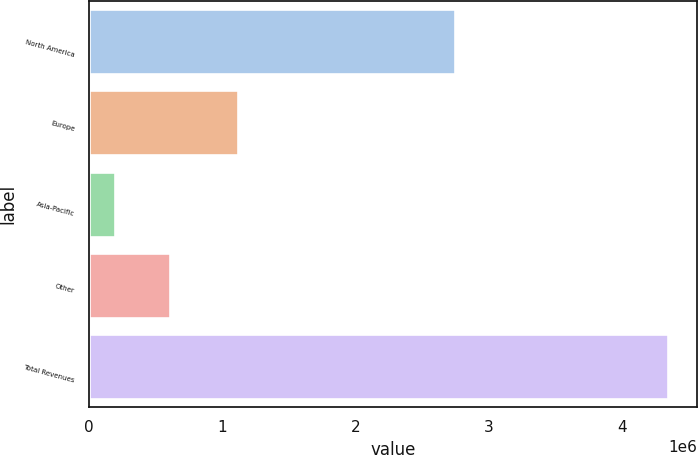<chart> <loc_0><loc_0><loc_500><loc_500><bar_chart><fcel>North America<fcel>Europe<fcel>Asia-Pacific<fcel>Other<fcel>Total Revenues<nl><fcel>2.74301e+06<fcel>1.1207e+06<fcel>198131<fcel>612823<fcel>4.34505e+06<nl></chart> 